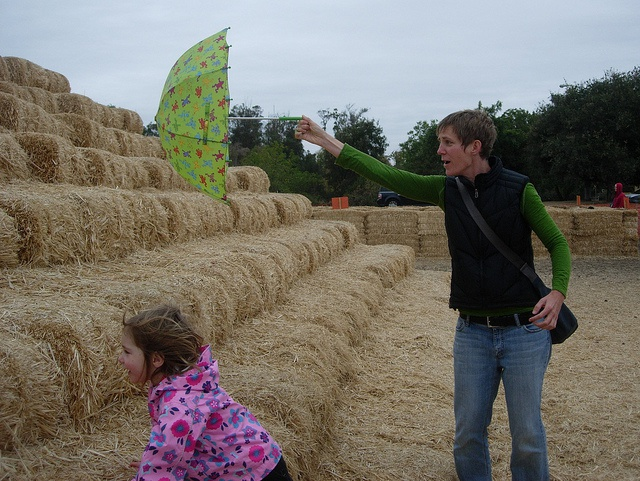Describe the objects in this image and their specific colors. I can see people in lightblue, black, gray, darkblue, and navy tones, people in lightblue, violet, black, gray, and purple tones, umbrella in lightblue, olive, and gray tones, handbag in lightblue, black, and gray tones, and car in lightblue, black, and gray tones in this image. 